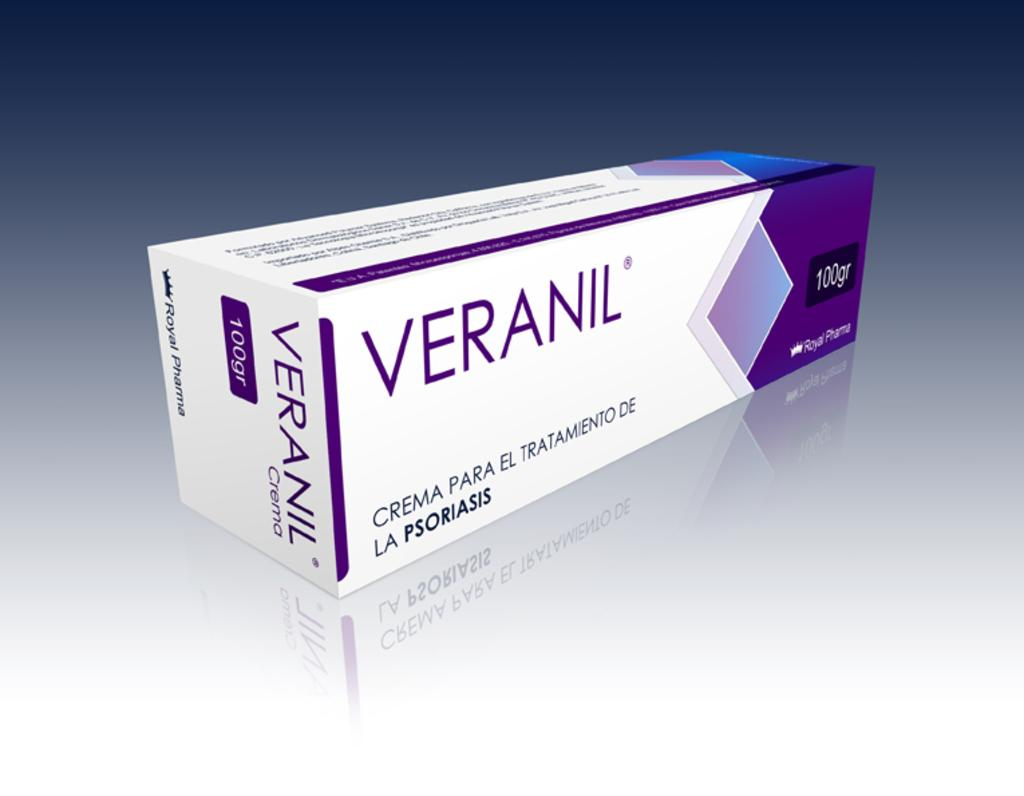<image>
Present a compact description of the photo's key features. A white and purple box contains 100 grams of Veranil. 